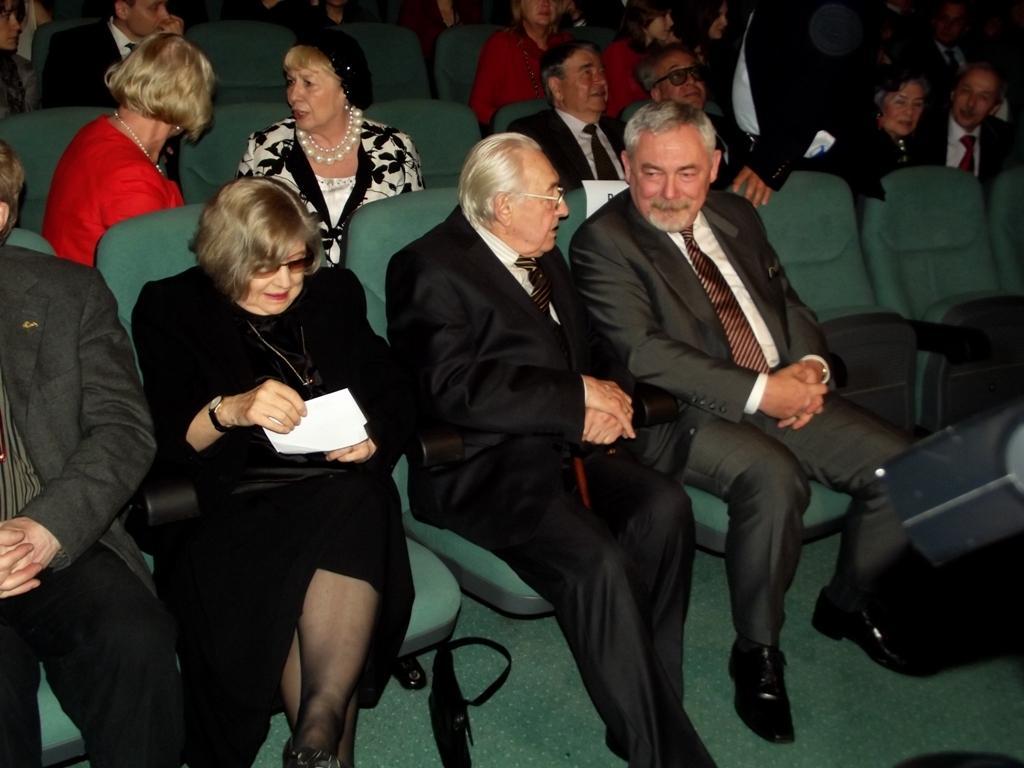Could you give a brief overview of what you see in this image? In this image I can see few people sitting on the chairs and they are wearing different color dresses. I can see a person is holding something. 